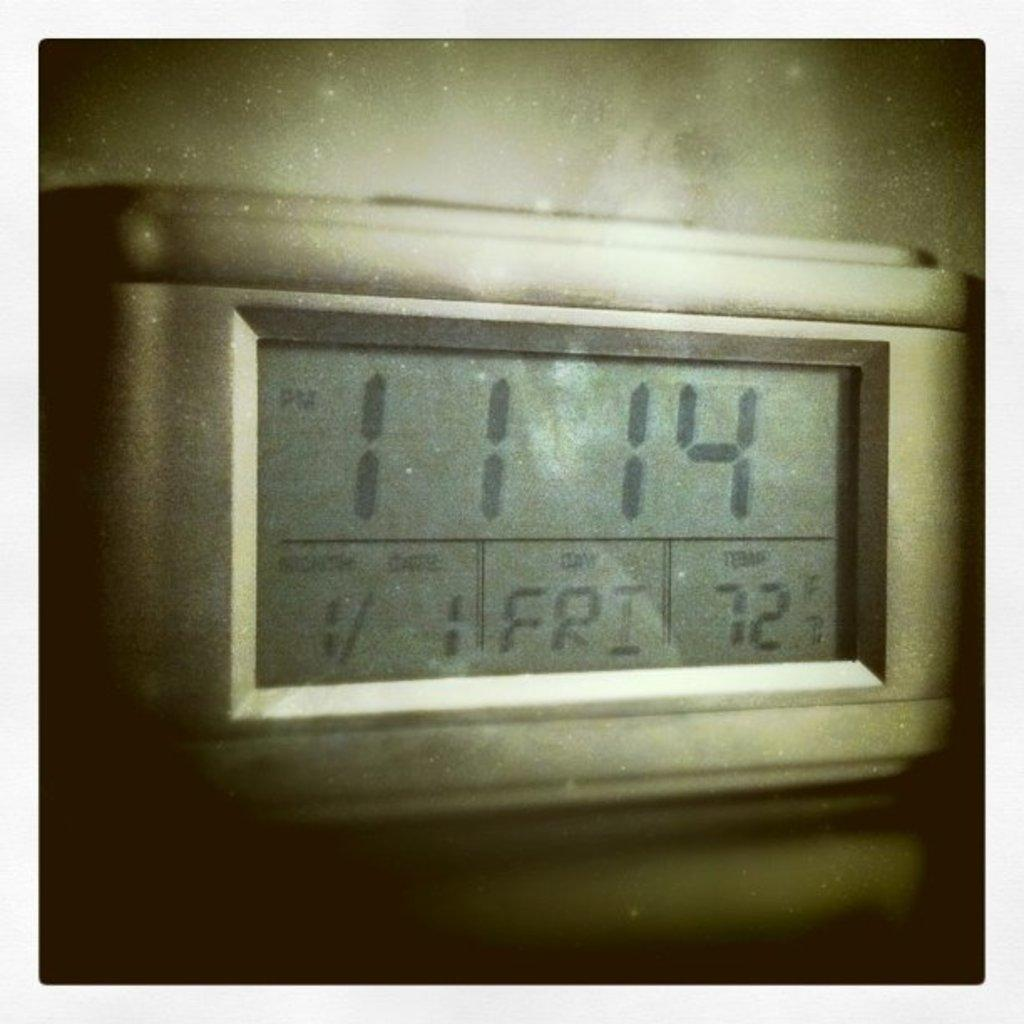<image>
Write a terse but informative summary of the picture. time on the screen states 11:14 friday  and temp os 72 